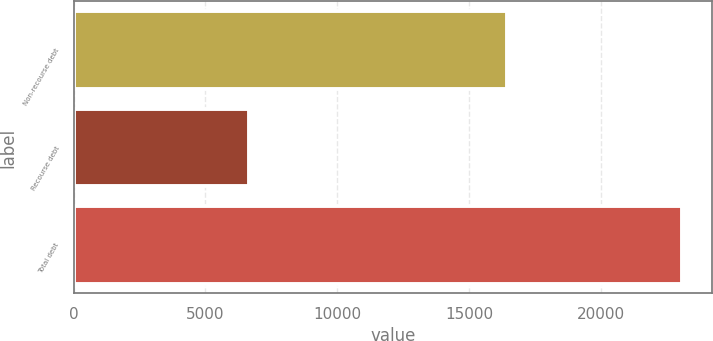Convert chart to OTSL. <chart><loc_0><loc_0><loc_500><loc_500><bar_chart><fcel>Non-recourse debt<fcel>Recourse debt<fcel>Total debt<nl><fcel>16425<fcel>6640<fcel>23065<nl></chart> 